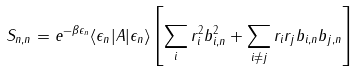Convert formula to latex. <formula><loc_0><loc_0><loc_500><loc_500>S _ { n , n } = e ^ { - \beta \epsilon _ { n } } \langle \epsilon _ { n } | A | \epsilon _ { n } \rangle \left [ \sum _ { i } r _ { i } ^ { 2 } b _ { i , n } ^ { 2 } + \sum _ { i \neq j } r _ { i } r _ { j } b _ { i , n } b _ { j , n } \right ]</formula> 